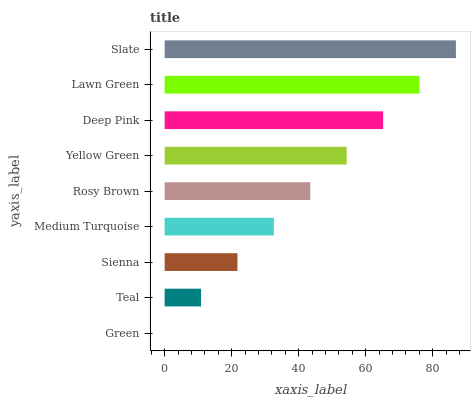Is Green the minimum?
Answer yes or no. Yes. Is Slate the maximum?
Answer yes or no. Yes. Is Teal the minimum?
Answer yes or no. No. Is Teal the maximum?
Answer yes or no. No. Is Teal greater than Green?
Answer yes or no. Yes. Is Green less than Teal?
Answer yes or no. Yes. Is Green greater than Teal?
Answer yes or no. No. Is Teal less than Green?
Answer yes or no. No. Is Rosy Brown the high median?
Answer yes or no. Yes. Is Rosy Brown the low median?
Answer yes or no. Yes. Is Yellow Green the high median?
Answer yes or no. No. Is Lawn Green the low median?
Answer yes or no. No. 